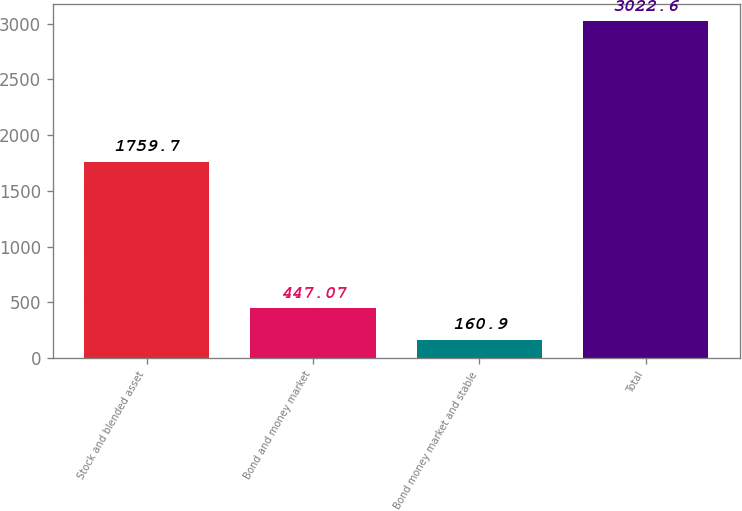Convert chart. <chart><loc_0><loc_0><loc_500><loc_500><bar_chart><fcel>Stock and blended asset<fcel>Bond and money market<fcel>Bond money market and stable<fcel>Total<nl><fcel>1759.7<fcel>447.07<fcel>160.9<fcel>3022.6<nl></chart> 